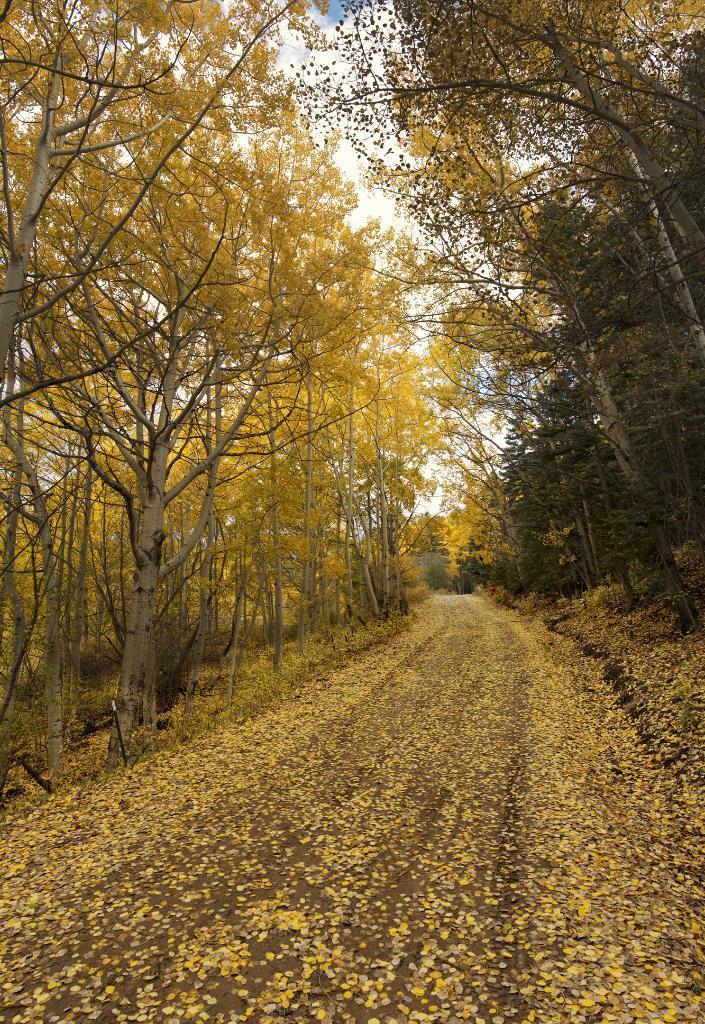Could you give a brief overview of what you see in this image? This image consists of a road covered with flowers. To the left and right, there are trees. At the top, there are clouds in the sky. 